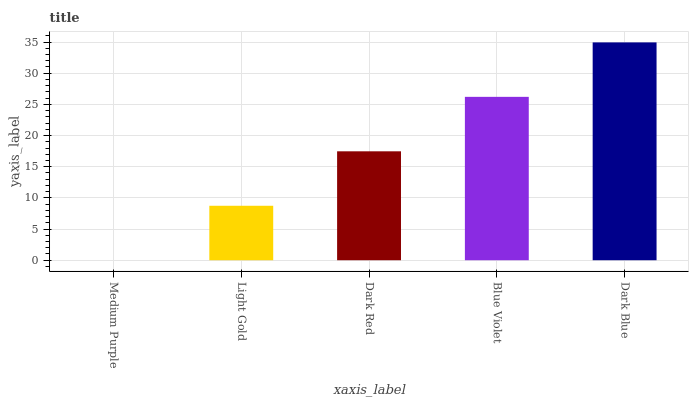Is Light Gold the minimum?
Answer yes or no. No. Is Light Gold the maximum?
Answer yes or no. No. Is Light Gold greater than Medium Purple?
Answer yes or no. Yes. Is Medium Purple less than Light Gold?
Answer yes or no. Yes. Is Medium Purple greater than Light Gold?
Answer yes or no. No. Is Light Gold less than Medium Purple?
Answer yes or no. No. Is Dark Red the high median?
Answer yes or no. Yes. Is Dark Red the low median?
Answer yes or no. Yes. Is Blue Violet the high median?
Answer yes or no. No. Is Dark Blue the low median?
Answer yes or no. No. 